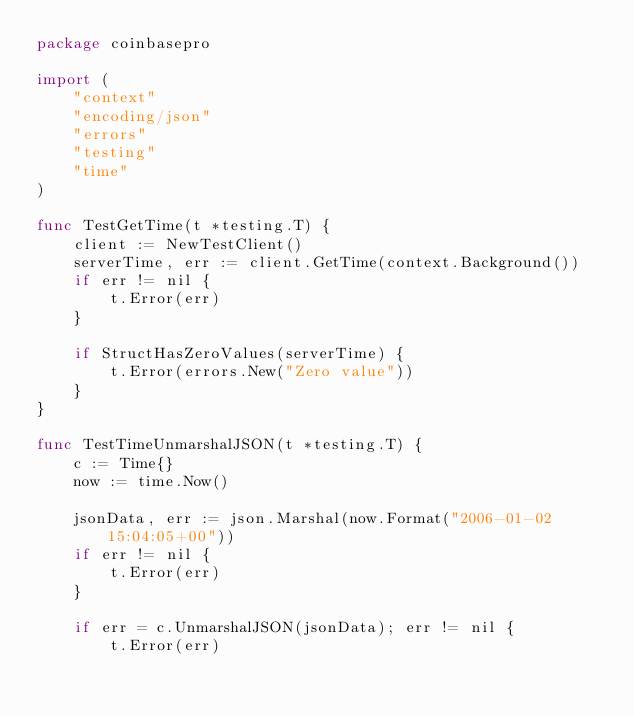<code> <loc_0><loc_0><loc_500><loc_500><_Go_>package coinbasepro

import (
	"context"
	"encoding/json"
	"errors"
	"testing"
	"time"
)

func TestGetTime(t *testing.T) {
	client := NewTestClient()
	serverTime, err := client.GetTime(context.Background())
	if err != nil {
		t.Error(err)
	}

	if StructHasZeroValues(serverTime) {
		t.Error(errors.New("Zero value"))
	}
}

func TestTimeUnmarshalJSON(t *testing.T) {
	c := Time{}
	now := time.Now()

	jsonData, err := json.Marshal(now.Format("2006-01-02 15:04:05+00"))
	if err != nil {
		t.Error(err)
	}

	if err = c.UnmarshalJSON(jsonData); err != nil {
		t.Error(err)</code> 